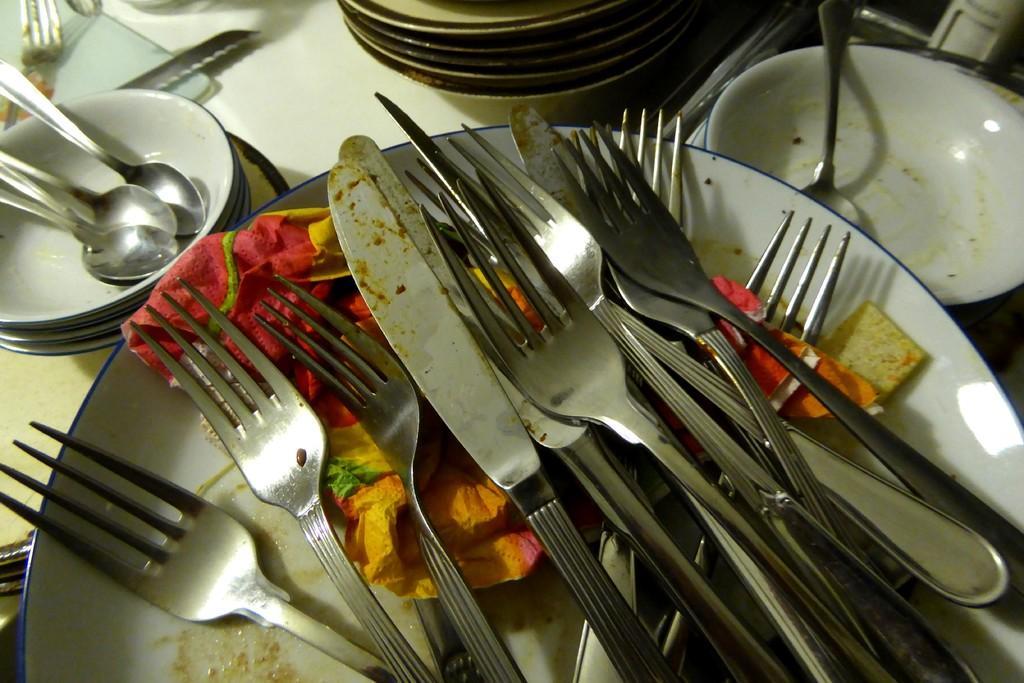Could you give a brief overview of what you see in this image? In this image we can see some used forks, knives and tissue papers in a plate placed on the table. We can also see some spoons in the bowls and a spoon in an empty bowl on the table. 